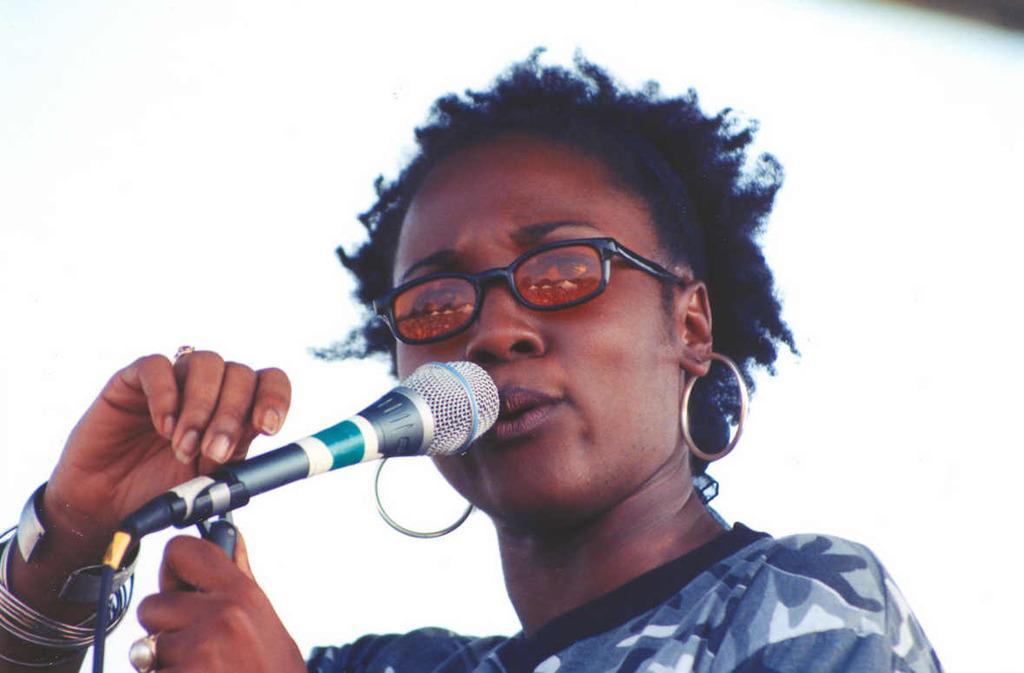How would you summarize this image in a sentence or two? In this picture I can see a woman is holding a microphone. The woman is wearing glasses and earrings. The background of the image is white. 